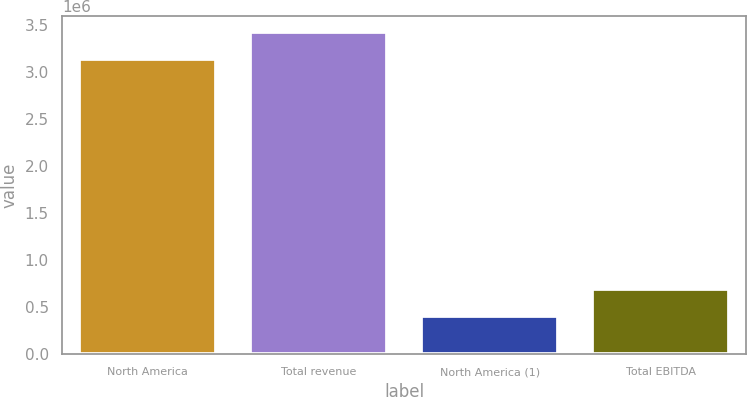Convert chart. <chart><loc_0><loc_0><loc_500><loc_500><bar_chart><fcel>North America<fcel>Total revenue<fcel>North America (1)<fcel>Total EBITDA<nl><fcel>3.13138e+06<fcel>3.41777e+06<fcel>405924<fcel>692318<nl></chart> 